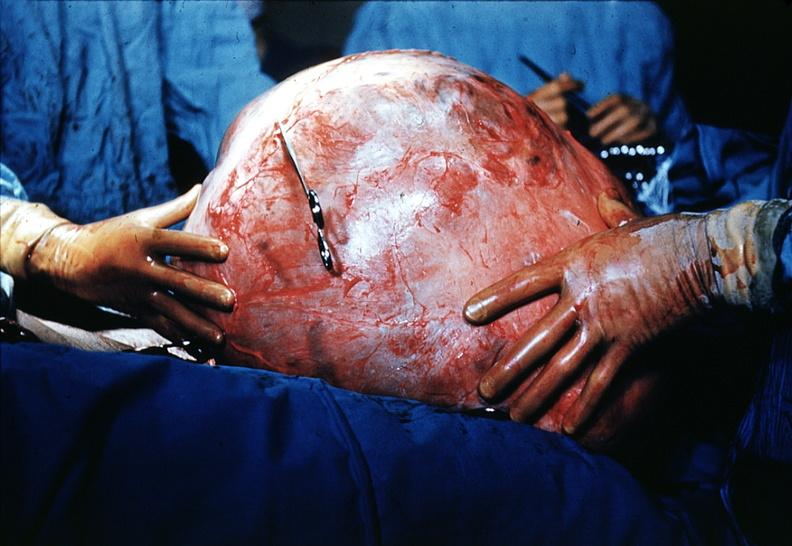what is present?
Answer the question using a single word or phrase. Mucinous cystadenocarcinoma 